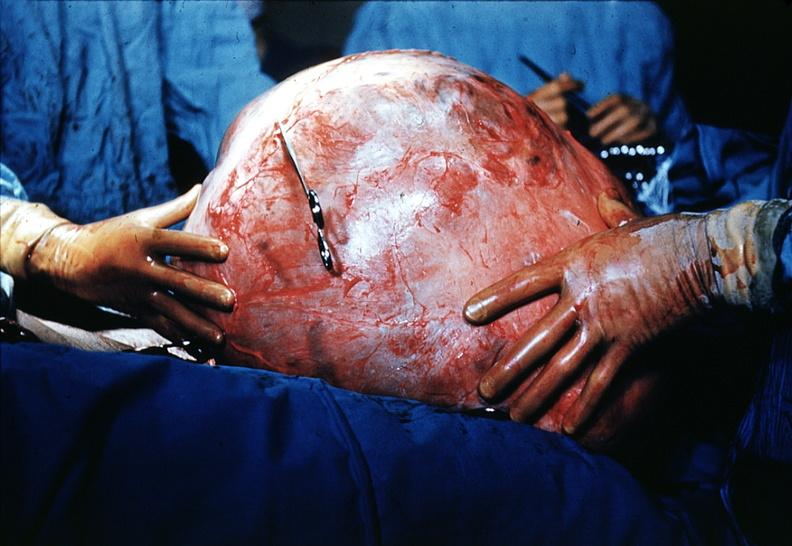what is present?
Answer the question using a single word or phrase. Mucinous cystadenocarcinoma 